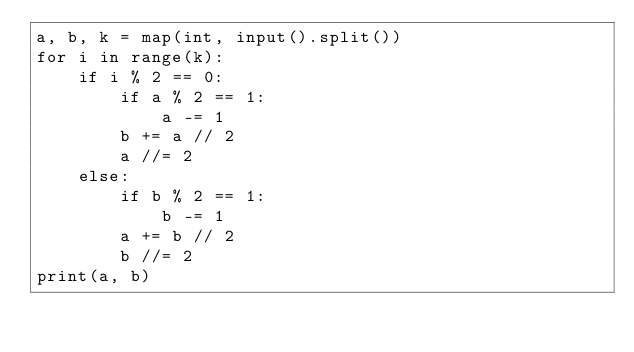Convert code to text. <code><loc_0><loc_0><loc_500><loc_500><_Python_>a, b, k = map(int, input().split())
for i in range(k):
    if i % 2 == 0:
        if a % 2 == 1:
            a -= 1
        b += a // 2
        a //= 2
    else:
        if b % 2 == 1:
            b -= 1
        a += b // 2
        b //= 2
print(a, b)</code> 